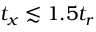<formula> <loc_0><loc_0><loc_500><loc_500>t _ { x } \lesssim 1 . 5 t _ { r }</formula> 